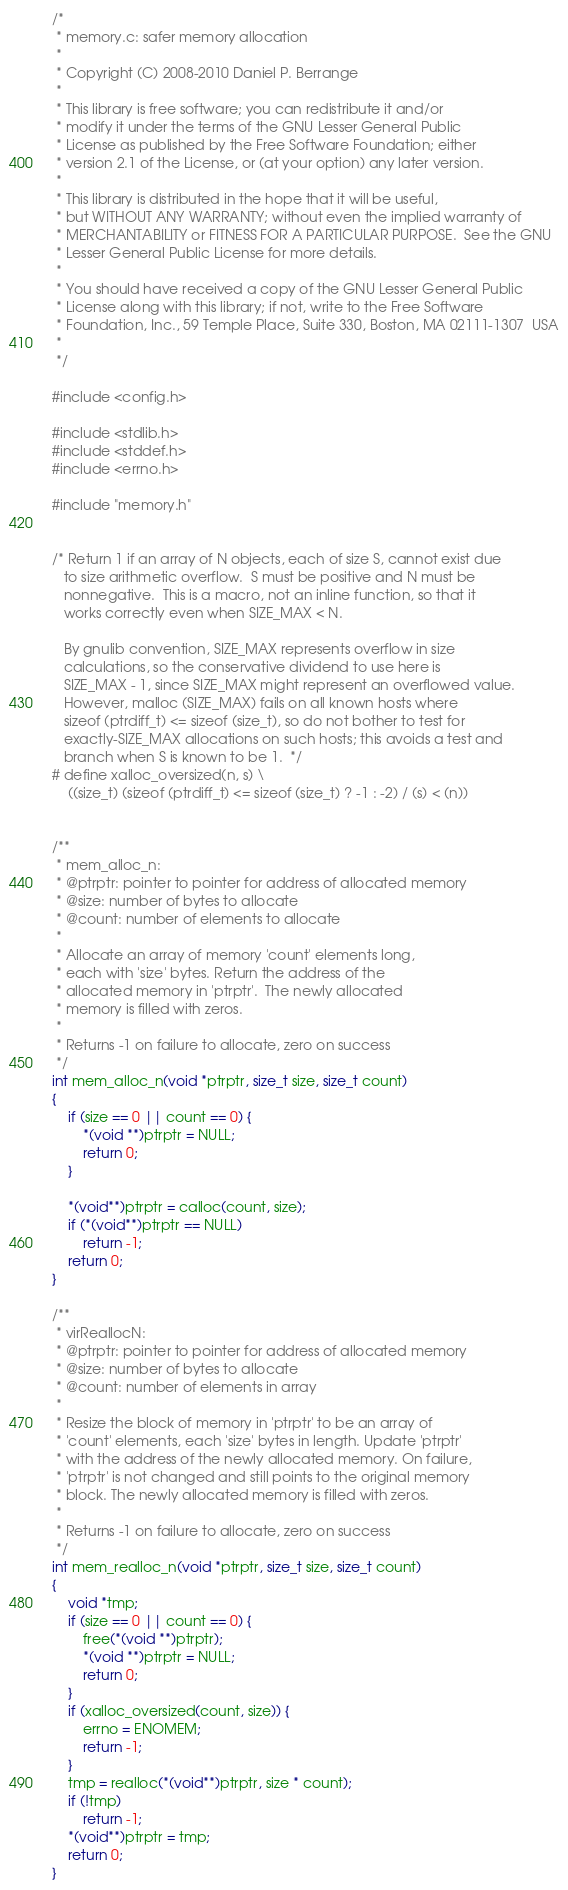<code> <loc_0><loc_0><loc_500><loc_500><_C_>/*
 * memory.c: safer memory allocation
 *
 * Copyright (C) 2008-2010 Daniel P. Berrange
 *
 * This library is free software; you can redistribute it and/or
 * modify it under the terms of the GNU Lesser General Public
 * License as published by the Free Software Foundation; either
 * version 2.1 of the License, or (at your option) any later version.
 *
 * This library is distributed in the hope that it will be useful,
 * but WITHOUT ANY WARRANTY; without even the implied warranty of
 * MERCHANTABILITY or FITNESS FOR A PARTICULAR PURPOSE.  See the GNU
 * Lesser General Public License for more details.
 *
 * You should have received a copy of the GNU Lesser General Public
 * License along with this library; if not, write to the Free Software
 * Foundation, Inc., 59 Temple Place, Suite 330, Boston, MA 02111-1307  USA
 *
 */

#include <config.h>

#include <stdlib.h>
#include <stddef.h>
#include <errno.h>

#include "memory.h"


/* Return 1 if an array of N objects, each of size S, cannot exist due
   to size arithmetic overflow.  S must be positive and N must be
   nonnegative.  This is a macro, not an inline function, so that it
   works correctly even when SIZE_MAX < N.

   By gnulib convention, SIZE_MAX represents overflow in size
   calculations, so the conservative dividend to use here is
   SIZE_MAX - 1, since SIZE_MAX might represent an overflowed value.
   However, malloc (SIZE_MAX) fails on all known hosts where
   sizeof (ptrdiff_t) <= sizeof (size_t), so do not bother to test for
   exactly-SIZE_MAX allocations on such hosts; this avoids a test and
   branch when S is known to be 1.  */
# define xalloc_oversized(n, s) \
    ((size_t) (sizeof (ptrdiff_t) <= sizeof (size_t) ? -1 : -2) / (s) < (n))


/**
 * mem_alloc_n:
 * @ptrptr: pointer to pointer for address of allocated memory
 * @size: number of bytes to allocate
 * @count: number of elements to allocate
 *
 * Allocate an array of memory 'count' elements long,
 * each with 'size' bytes. Return the address of the
 * allocated memory in 'ptrptr'.  The newly allocated
 * memory is filled with zeros.
 *
 * Returns -1 on failure to allocate, zero on success
 */
int mem_alloc_n(void *ptrptr, size_t size, size_t count)
{
    if (size == 0 || count == 0) {
        *(void **)ptrptr = NULL;
        return 0;
    }

    *(void**)ptrptr = calloc(count, size);
    if (*(void**)ptrptr == NULL)
        return -1;
    return 0;
}

/**
 * virReallocN:
 * @ptrptr: pointer to pointer for address of allocated memory
 * @size: number of bytes to allocate
 * @count: number of elements in array
 *
 * Resize the block of memory in 'ptrptr' to be an array of
 * 'count' elements, each 'size' bytes in length. Update 'ptrptr'
 * with the address of the newly allocated memory. On failure,
 * 'ptrptr' is not changed and still points to the original memory
 * block. The newly allocated memory is filled with zeros.
 *
 * Returns -1 on failure to allocate, zero on success
 */
int mem_realloc_n(void *ptrptr, size_t size, size_t count)
{
    void *tmp;
    if (size == 0 || count == 0) {
        free(*(void **)ptrptr);
        *(void **)ptrptr = NULL;
        return 0;
    }
    if (xalloc_oversized(count, size)) {
        errno = ENOMEM;
        return -1;
    }
    tmp = realloc(*(void**)ptrptr, size * count);
    if (!tmp)
        return -1;
    *(void**)ptrptr = tmp;
    return 0;
}
</code> 